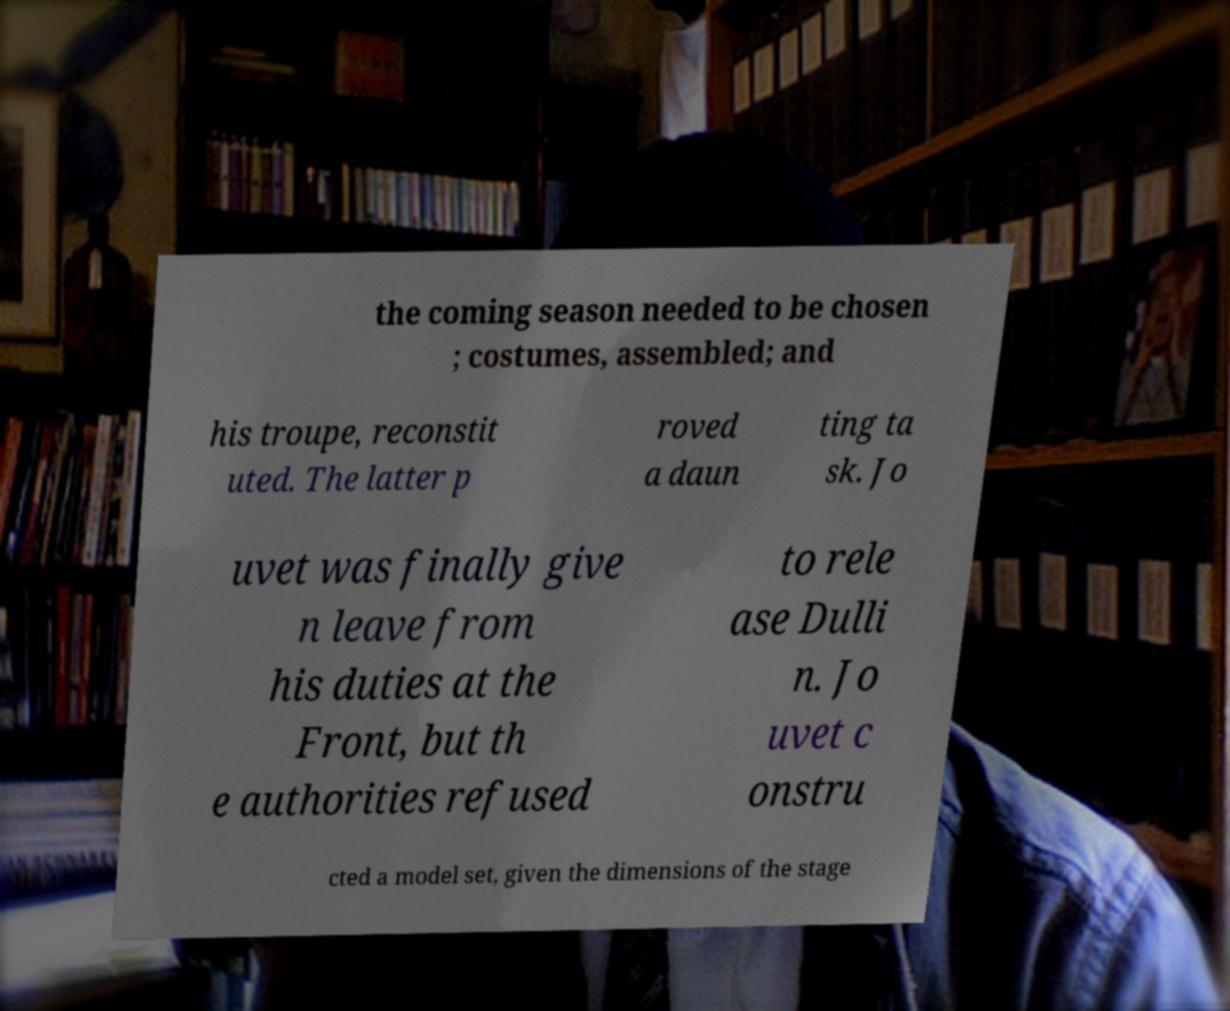Could you assist in decoding the text presented in this image and type it out clearly? the coming season needed to be chosen ; costumes, assembled; and his troupe, reconstit uted. The latter p roved a daun ting ta sk. Jo uvet was finally give n leave from his duties at the Front, but th e authorities refused to rele ase Dulli n. Jo uvet c onstru cted a model set, given the dimensions of the stage 